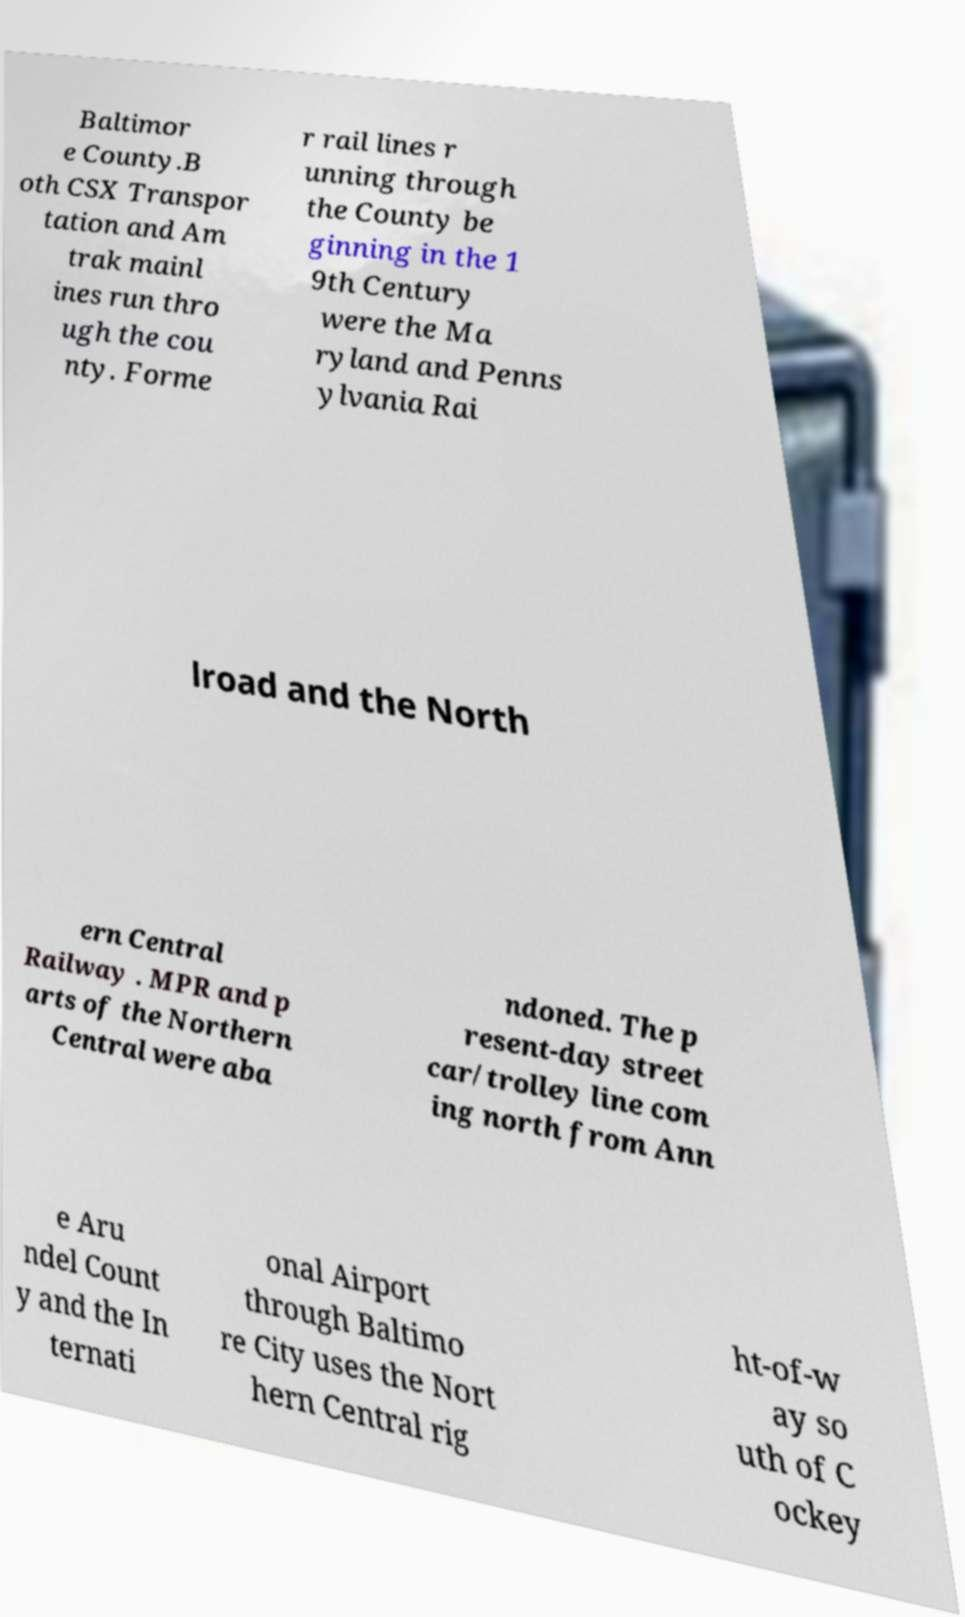Please read and relay the text visible in this image. What does it say? Baltimor e County.B oth CSX Transpor tation and Am trak mainl ines run thro ugh the cou nty. Forme r rail lines r unning through the County be ginning in the 1 9th Century were the Ma ryland and Penns ylvania Rai lroad and the North ern Central Railway . MPR and p arts of the Northern Central were aba ndoned. The p resent-day street car/trolley line com ing north from Ann e Aru ndel Count y and the In ternati onal Airport through Baltimo re City uses the Nort hern Central rig ht-of-w ay so uth of C ockey 